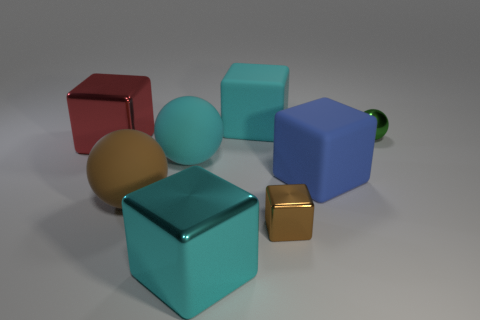What number of brown things are either tiny shiny balls or big matte things?
Your answer should be very brief. 1. How many small purple metal things are the same shape as the big red metallic thing?
Your response must be concise. 0. What is the material of the red cube?
Your answer should be compact. Metal. Are there an equal number of large cyan matte things left of the large cyan metal thing and cyan balls?
Keep it short and to the point. Yes. What is the shape of the brown matte thing that is the same size as the red thing?
Provide a succinct answer. Sphere. There is a matte block in front of the green sphere; are there any blue rubber blocks in front of it?
Provide a succinct answer. No. How many large objects are green metal spheres or cyan matte spheres?
Offer a very short reply. 1. Is there another cube of the same size as the blue block?
Make the answer very short. Yes. How many rubber objects are small blue things or big blue cubes?
Keep it short and to the point. 1. There is a big object that is the same color as the tiny shiny block; what is its shape?
Ensure brevity in your answer.  Sphere. 